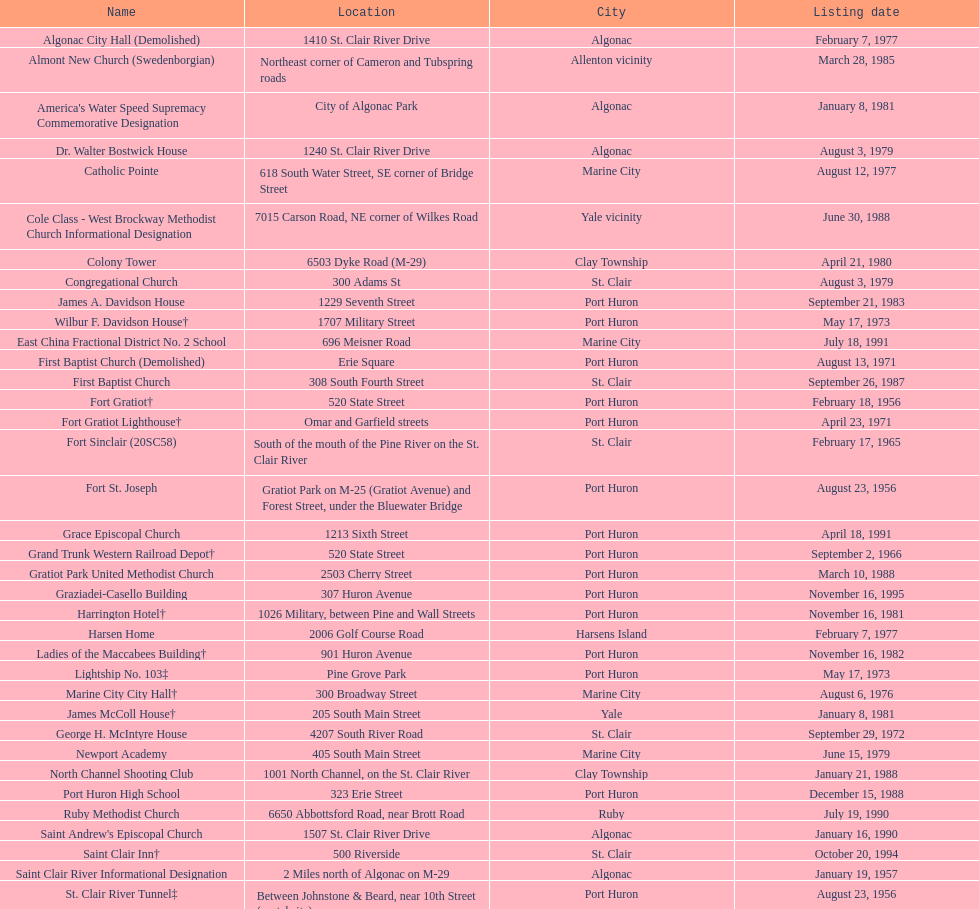Which city boasts the most historic sites, regardless of their current existence or demolition? Port Huron. 